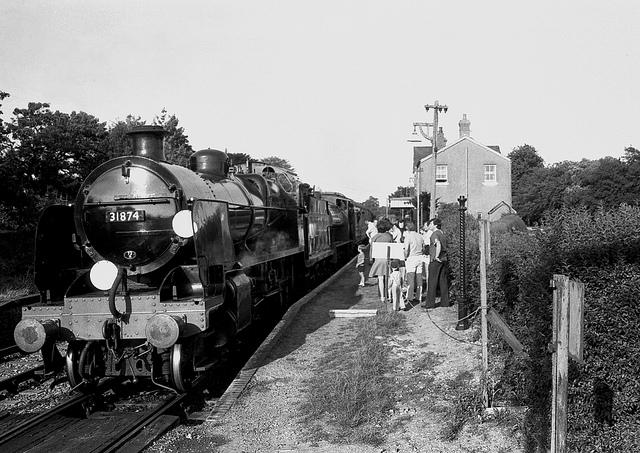What color are the numbers on the trains?
Keep it brief. White. Is this shot in color?
Give a very brief answer. No. Is the train blowing steam?
Answer briefly. No. Are the people boarding the train?
Be succinct. Yes. What is the engine's number?
Answer briefly. 31874. 